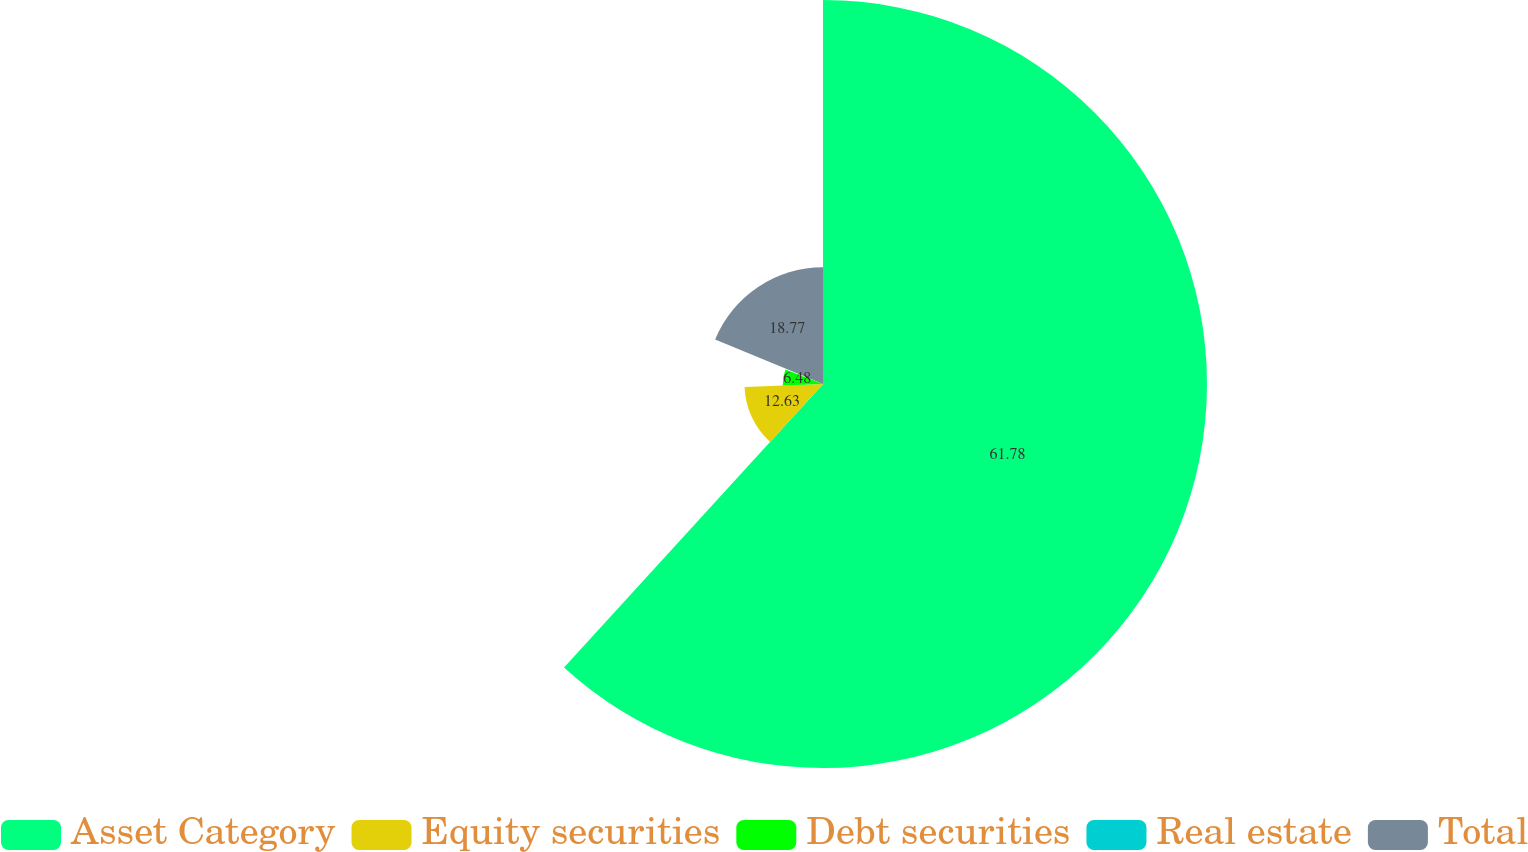<chart> <loc_0><loc_0><loc_500><loc_500><pie_chart><fcel>Asset Category<fcel>Equity securities<fcel>Debt securities<fcel>Real estate<fcel>Total<nl><fcel>61.78%<fcel>12.63%<fcel>6.48%<fcel>0.34%<fcel>18.77%<nl></chart> 